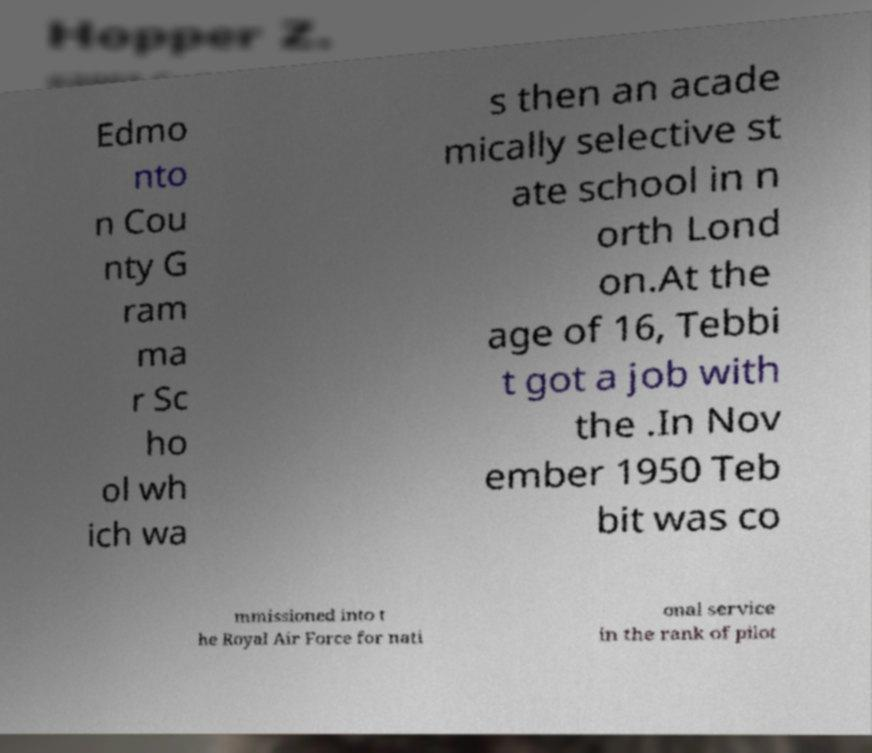Could you assist in decoding the text presented in this image and type it out clearly? Edmo nto n Cou nty G ram ma r Sc ho ol wh ich wa s then an acade mically selective st ate school in n orth Lond on.At the age of 16, Tebbi t got a job with the .In Nov ember 1950 Teb bit was co mmissioned into t he Royal Air Force for nati onal service in the rank of pilot 